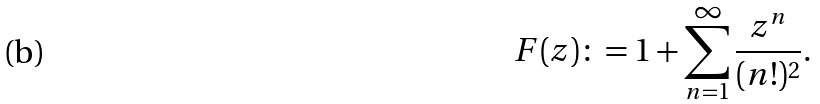<formula> <loc_0><loc_0><loc_500><loc_500>F ( z ) \colon = 1 + \sum ^ { \infty } _ { n = 1 } \frac { z ^ { n } } { ( n ! ) ^ { 2 } } .</formula> 